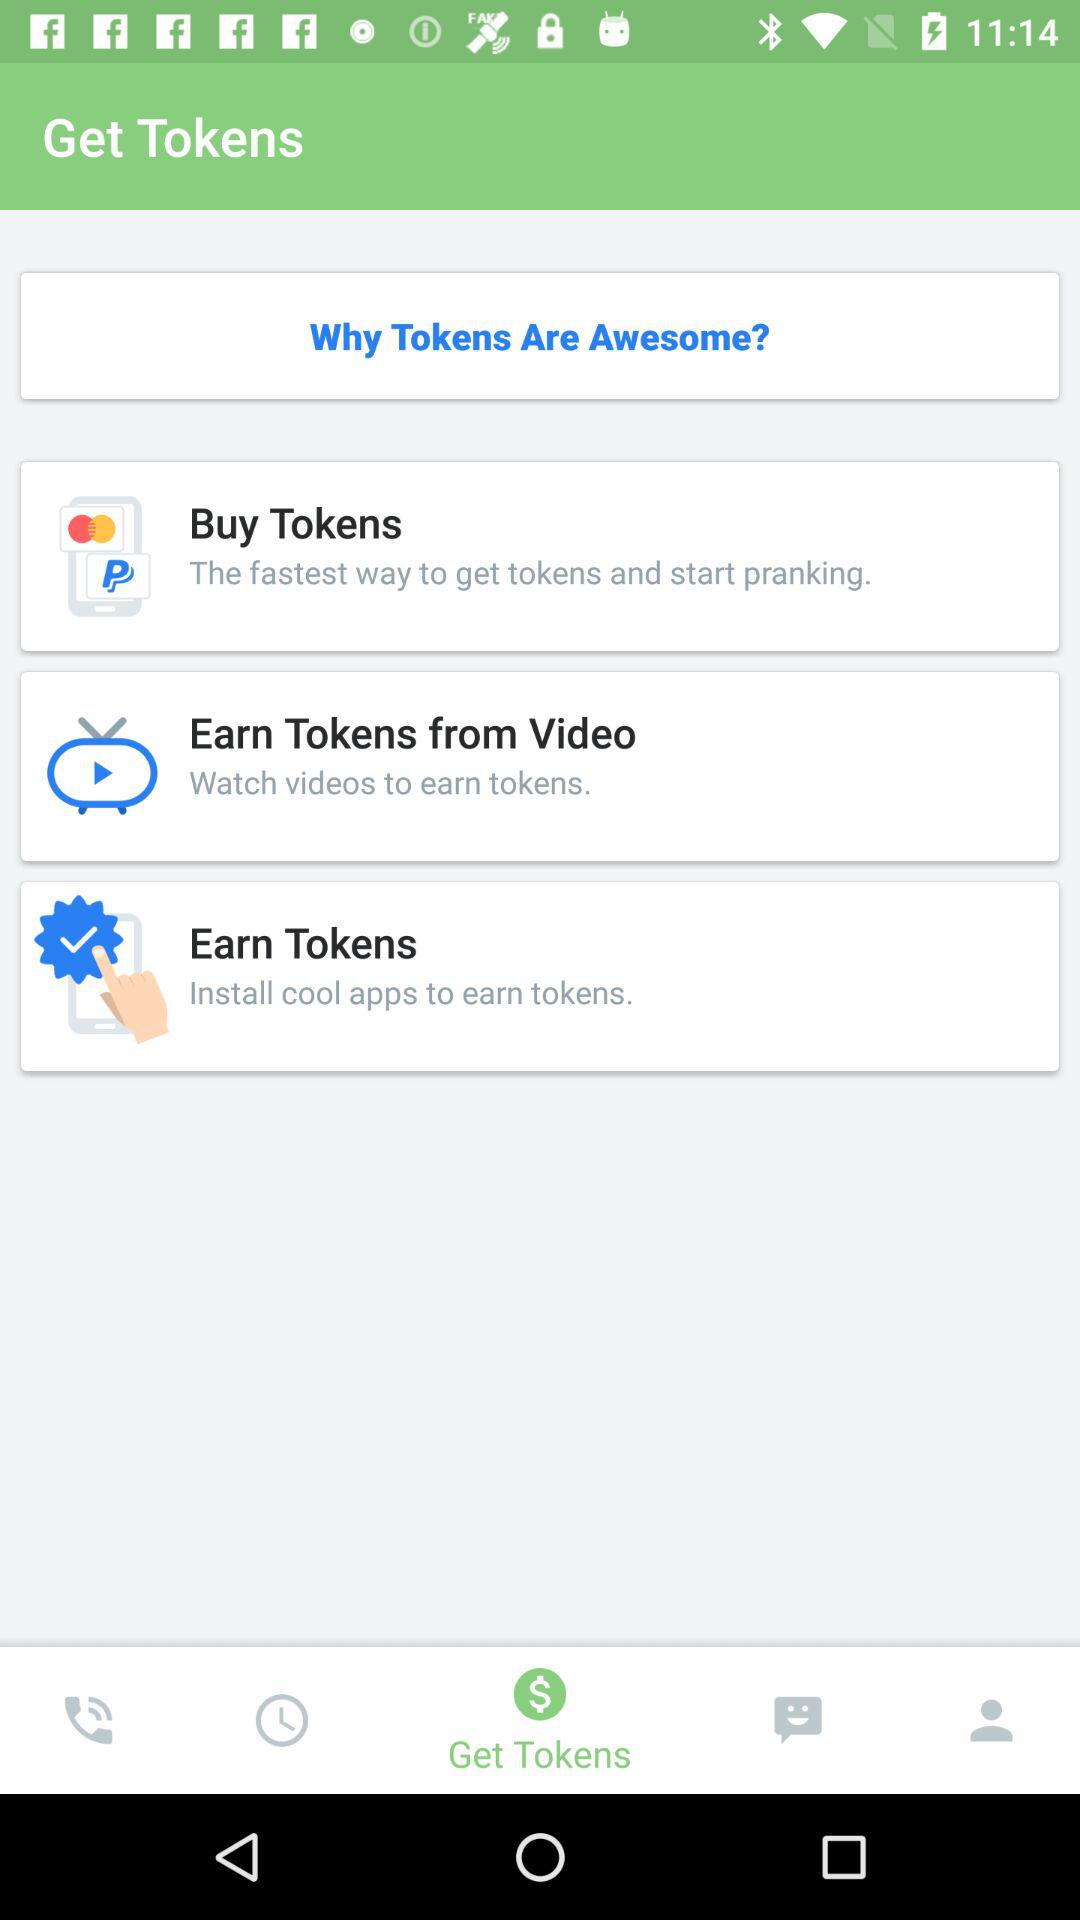How can we "Earn Tokens"? We can install cool apps to earn tokens. 